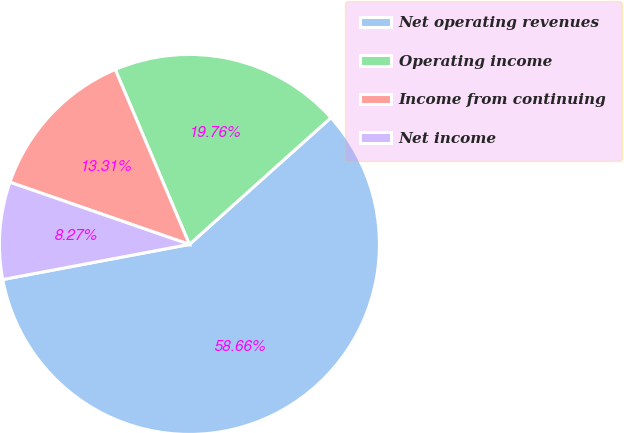Convert chart to OTSL. <chart><loc_0><loc_0><loc_500><loc_500><pie_chart><fcel>Net operating revenues<fcel>Operating income<fcel>Income from continuing<fcel>Net income<nl><fcel>58.67%<fcel>19.76%<fcel>13.31%<fcel>8.27%<nl></chart> 